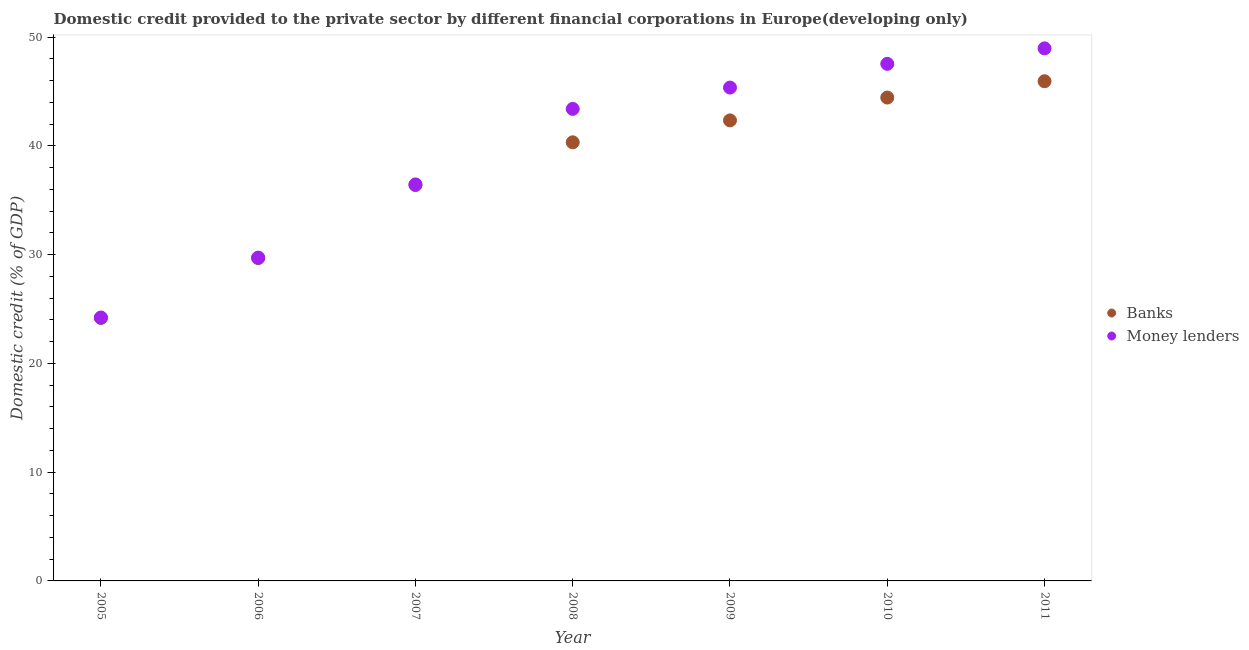Is the number of dotlines equal to the number of legend labels?
Give a very brief answer. Yes. What is the domestic credit provided by money lenders in 2010?
Your answer should be very brief. 47.54. Across all years, what is the maximum domestic credit provided by banks?
Offer a very short reply. 45.94. Across all years, what is the minimum domestic credit provided by money lenders?
Offer a terse response. 24.22. What is the total domestic credit provided by money lenders in the graph?
Offer a very short reply. 275.65. What is the difference between the domestic credit provided by banks in 2009 and that in 2011?
Your response must be concise. -3.6. What is the difference between the domestic credit provided by money lenders in 2007 and the domestic credit provided by banks in 2008?
Ensure brevity in your answer.  -3.87. What is the average domestic credit provided by money lenders per year?
Offer a very short reply. 39.38. In the year 2008, what is the difference between the domestic credit provided by banks and domestic credit provided by money lenders?
Provide a short and direct response. -3.07. In how many years, is the domestic credit provided by banks greater than 6 %?
Keep it short and to the point. 7. What is the ratio of the domestic credit provided by money lenders in 2005 to that in 2010?
Keep it short and to the point. 0.51. What is the difference between the highest and the second highest domestic credit provided by money lenders?
Give a very brief answer. 1.42. What is the difference between the highest and the lowest domestic credit provided by banks?
Make the answer very short. 21.76. In how many years, is the domestic credit provided by money lenders greater than the average domestic credit provided by money lenders taken over all years?
Provide a succinct answer. 4. Does the domestic credit provided by money lenders monotonically increase over the years?
Your response must be concise. Yes. Is the domestic credit provided by banks strictly greater than the domestic credit provided by money lenders over the years?
Provide a succinct answer. No. What is the difference between two consecutive major ticks on the Y-axis?
Your response must be concise. 10. Does the graph contain any zero values?
Provide a short and direct response. No. How many legend labels are there?
Provide a short and direct response. 2. What is the title of the graph?
Keep it short and to the point. Domestic credit provided to the private sector by different financial corporations in Europe(developing only). Does "Measles" appear as one of the legend labels in the graph?
Give a very brief answer. No. What is the label or title of the Y-axis?
Offer a very short reply. Domestic credit (% of GDP). What is the Domestic credit (% of GDP) of Banks in 2005?
Offer a terse response. 24.18. What is the Domestic credit (% of GDP) of Money lenders in 2005?
Offer a very short reply. 24.22. What is the Domestic credit (% of GDP) of Banks in 2006?
Ensure brevity in your answer.  29.68. What is the Domestic credit (% of GDP) of Money lenders in 2006?
Give a very brief answer. 29.73. What is the Domestic credit (% of GDP) of Banks in 2007?
Your answer should be compact. 36.39. What is the Domestic credit (% of GDP) of Money lenders in 2007?
Provide a short and direct response. 36.45. What is the Domestic credit (% of GDP) of Banks in 2008?
Provide a succinct answer. 40.32. What is the Domestic credit (% of GDP) of Money lenders in 2008?
Your answer should be very brief. 43.4. What is the Domestic credit (% of GDP) in Banks in 2009?
Your response must be concise. 42.34. What is the Domestic credit (% of GDP) of Money lenders in 2009?
Your response must be concise. 45.36. What is the Domestic credit (% of GDP) in Banks in 2010?
Give a very brief answer. 44.44. What is the Domestic credit (% of GDP) of Money lenders in 2010?
Keep it short and to the point. 47.54. What is the Domestic credit (% of GDP) in Banks in 2011?
Your answer should be compact. 45.94. What is the Domestic credit (% of GDP) in Money lenders in 2011?
Provide a succinct answer. 48.96. Across all years, what is the maximum Domestic credit (% of GDP) of Banks?
Offer a very short reply. 45.94. Across all years, what is the maximum Domestic credit (% of GDP) in Money lenders?
Give a very brief answer. 48.96. Across all years, what is the minimum Domestic credit (% of GDP) in Banks?
Provide a succinct answer. 24.18. Across all years, what is the minimum Domestic credit (% of GDP) in Money lenders?
Your response must be concise. 24.22. What is the total Domestic credit (% of GDP) of Banks in the graph?
Offer a terse response. 263.29. What is the total Domestic credit (% of GDP) in Money lenders in the graph?
Offer a terse response. 275.65. What is the difference between the Domestic credit (% of GDP) of Banks in 2005 and that in 2006?
Give a very brief answer. -5.5. What is the difference between the Domestic credit (% of GDP) of Money lenders in 2005 and that in 2006?
Make the answer very short. -5.51. What is the difference between the Domestic credit (% of GDP) in Banks in 2005 and that in 2007?
Your answer should be compact. -12.21. What is the difference between the Domestic credit (% of GDP) of Money lenders in 2005 and that in 2007?
Make the answer very short. -12.24. What is the difference between the Domestic credit (% of GDP) of Banks in 2005 and that in 2008?
Make the answer very short. -16.15. What is the difference between the Domestic credit (% of GDP) in Money lenders in 2005 and that in 2008?
Keep it short and to the point. -19.18. What is the difference between the Domestic credit (% of GDP) of Banks in 2005 and that in 2009?
Offer a very short reply. -18.16. What is the difference between the Domestic credit (% of GDP) of Money lenders in 2005 and that in 2009?
Make the answer very short. -21.14. What is the difference between the Domestic credit (% of GDP) in Banks in 2005 and that in 2010?
Ensure brevity in your answer.  -20.26. What is the difference between the Domestic credit (% of GDP) in Money lenders in 2005 and that in 2010?
Your answer should be compact. -23.32. What is the difference between the Domestic credit (% of GDP) in Banks in 2005 and that in 2011?
Give a very brief answer. -21.76. What is the difference between the Domestic credit (% of GDP) of Money lenders in 2005 and that in 2011?
Offer a very short reply. -24.75. What is the difference between the Domestic credit (% of GDP) of Banks in 2006 and that in 2007?
Offer a very short reply. -6.72. What is the difference between the Domestic credit (% of GDP) in Money lenders in 2006 and that in 2007?
Provide a short and direct response. -6.73. What is the difference between the Domestic credit (% of GDP) of Banks in 2006 and that in 2008?
Ensure brevity in your answer.  -10.65. What is the difference between the Domestic credit (% of GDP) in Money lenders in 2006 and that in 2008?
Offer a very short reply. -13.67. What is the difference between the Domestic credit (% of GDP) in Banks in 2006 and that in 2009?
Make the answer very short. -12.66. What is the difference between the Domestic credit (% of GDP) in Money lenders in 2006 and that in 2009?
Your answer should be very brief. -15.63. What is the difference between the Domestic credit (% of GDP) of Banks in 2006 and that in 2010?
Keep it short and to the point. -14.76. What is the difference between the Domestic credit (% of GDP) of Money lenders in 2006 and that in 2010?
Your answer should be compact. -17.81. What is the difference between the Domestic credit (% of GDP) of Banks in 2006 and that in 2011?
Your answer should be compact. -16.26. What is the difference between the Domestic credit (% of GDP) in Money lenders in 2006 and that in 2011?
Your answer should be compact. -19.24. What is the difference between the Domestic credit (% of GDP) of Banks in 2007 and that in 2008?
Your answer should be very brief. -3.93. What is the difference between the Domestic credit (% of GDP) in Money lenders in 2007 and that in 2008?
Offer a very short reply. -6.94. What is the difference between the Domestic credit (% of GDP) in Banks in 2007 and that in 2009?
Offer a terse response. -5.95. What is the difference between the Domestic credit (% of GDP) of Money lenders in 2007 and that in 2009?
Your answer should be compact. -8.9. What is the difference between the Domestic credit (% of GDP) in Banks in 2007 and that in 2010?
Your answer should be compact. -8.04. What is the difference between the Domestic credit (% of GDP) in Money lenders in 2007 and that in 2010?
Keep it short and to the point. -11.08. What is the difference between the Domestic credit (% of GDP) in Banks in 2007 and that in 2011?
Your answer should be compact. -9.55. What is the difference between the Domestic credit (% of GDP) of Money lenders in 2007 and that in 2011?
Ensure brevity in your answer.  -12.51. What is the difference between the Domestic credit (% of GDP) of Banks in 2008 and that in 2009?
Your answer should be compact. -2.01. What is the difference between the Domestic credit (% of GDP) in Money lenders in 2008 and that in 2009?
Give a very brief answer. -1.96. What is the difference between the Domestic credit (% of GDP) of Banks in 2008 and that in 2010?
Ensure brevity in your answer.  -4.11. What is the difference between the Domestic credit (% of GDP) of Money lenders in 2008 and that in 2010?
Provide a succinct answer. -4.14. What is the difference between the Domestic credit (% of GDP) of Banks in 2008 and that in 2011?
Your answer should be very brief. -5.62. What is the difference between the Domestic credit (% of GDP) in Money lenders in 2008 and that in 2011?
Provide a short and direct response. -5.57. What is the difference between the Domestic credit (% of GDP) in Banks in 2009 and that in 2010?
Your answer should be compact. -2.1. What is the difference between the Domestic credit (% of GDP) in Money lenders in 2009 and that in 2010?
Keep it short and to the point. -2.18. What is the difference between the Domestic credit (% of GDP) in Banks in 2009 and that in 2011?
Make the answer very short. -3.6. What is the difference between the Domestic credit (% of GDP) in Money lenders in 2009 and that in 2011?
Provide a short and direct response. -3.6. What is the difference between the Domestic credit (% of GDP) of Banks in 2010 and that in 2011?
Provide a short and direct response. -1.5. What is the difference between the Domestic credit (% of GDP) of Money lenders in 2010 and that in 2011?
Your response must be concise. -1.42. What is the difference between the Domestic credit (% of GDP) in Banks in 2005 and the Domestic credit (% of GDP) in Money lenders in 2006?
Make the answer very short. -5.55. What is the difference between the Domestic credit (% of GDP) in Banks in 2005 and the Domestic credit (% of GDP) in Money lenders in 2007?
Provide a succinct answer. -12.28. What is the difference between the Domestic credit (% of GDP) in Banks in 2005 and the Domestic credit (% of GDP) in Money lenders in 2008?
Your answer should be very brief. -19.22. What is the difference between the Domestic credit (% of GDP) of Banks in 2005 and the Domestic credit (% of GDP) of Money lenders in 2009?
Ensure brevity in your answer.  -21.18. What is the difference between the Domestic credit (% of GDP) of Banks in 2005 and the Domestic credit (% of GDP) of Money lenders in 2010?
Ensure brevity in your answer.  -23.36. What is the difference between the Domestic credit (% of GDP) of Banks in 2005 and the Domestic credit (% of GDP) of Money lenders in 2011?
Make the answer very short. -24.78. What is the difference between the Domestic credit (% of GDP) in Banks in 2006 and the Domestic credit (% of GDP) in Money lenders in 2007?
Your answer should be compact. -6.78. What is the difference between the Domestic credit (% of GDP) of Banks in 2006 and the Domestic credit (% of GDP) of Money lenders in 2008?
Your answer should be compact. -13.72. What is the difference between the Domestic credit (% of GDP) of Banks in 2006 and the Domestic credit (% of GDP) of Money lenders in 2009?
Your response must be concise. -15.68. What is the difference between the Domestic credit (% of GDP) of Banks in 2006 and the Domestic credit (% of GDP) of Money lenders in 2010?
Keep it short and to the point. -17.86. What is the difference between the Domestic credit (% of GDP) of Banks in 2006 and the Domestic credit (% of GDP) of Money lenders in 2011?
Ensure brevity in your answer.  -19.28. What is the difference between the Domestic credit (% of GDP) of Banks in 2007 and the Domestic credit (% of GDP) of Money lenders in 2008?
Offer a very short reply. -7. What is the difference between the Domestic credit (% of GDP) in Banks in 2007 and the Domestic credit (% of GDP) in Money lenders in 2009?
Your response must be concise. -8.96. What is the difference between the Domestic credit (% of GDP) of Banks in 2007 and the Domestic credit (% of GDP) of Money lenders in 2010?
Ensure brevity in your answer.  -11.14. What is the difference between the Domestic credit (% of GDP) of Banks in 2007 and the Domestic credit (% of GDP) of Money lenders in 2011?
Your response must be concise. -12.57. What is the difference between the Domestic credit (% of GDP) in Banks in 2008 and the Domestic credit (% of GDP) in Money lenders in 2009?
Your answer should be very brief. -5.03. What is the difference between the Domestic credit (% of GDP) of Banks in 2008 and the Domestic credit (% of GDP) of Money lenders in 2010?
Ensure brevity in your answer.  -7.21. What is the difference between the Domestic credit (% of GDP) in Banks in 2008 and the Domestic credit (% of GDP) in Money lenders in 2011?
Your response must be concise. -8.64. What is the difference between the Domestic credit (% of GDP) of Banks in 2009 and the Domestic credit (% of GDP) of Money lenders in 2010?
Provide a succinct answer. -5.2. What is the difference between the Domestic credit (% of GDP) of Banks in 2009 and the Domestic credit (% of GDP) of Money lenders in 2011?
Ensure brevity in your answer.  -6.62. What is the difference between the Domestic credit (% of GDP) in Banks in 2010 and the Domestic credit (% of GDP) in Money lenders in 2011?
Keep it short and to the point. -4.52. What is the average Domestic credit (% of GDP) in Banks per year?
Offer a terse response. 37.61. What is the average Domestic credit (% of GDP) in Money lenders per year?
Your answer should be very brief. 39.38. In the year 2005, what is the difference between the Domestic credit (% of GDP) in Banks and Domestic credit (% of GDP) in Money lenders?
Give a very brief answer. -0.04. In the year 2006, what is the difference between the Domestic credit (% of GDP) of Banks and Domestic credit (% of GDP) of Money lenders?
Your answer should be very brief. -0.05. In the year 2007, what is the difference between the Domestic credit (% of GDP) of Banks and Domestic credit (% of GDP) of Money lenders?
Keep it short and to the point. -0.06. In the year 2008, what is the difference between the Domestic credit (% of GDP) of Banks and Domestic credit (% of GDP) of Money lenders?
Ensure brevity in your answer.  -3.07. In the year 2009, what is the difference between the Domestic credit (% of GDP) of Banks and Domestic credit (% of GDP) of Money lenders?
Your response must be concise. -3.02. In the year 2010, what is the difference between the Domestic credit (% of GDP) in Banks and Domestic credit (% of GDP) in Money lenders?
Your answer should be compact. -3.1. In the year 2011, what is the difference between the Domestic credit (% of GDP) in Banks and Domestic credit (% of GDP) in Money lenders?
Keep it short and to the point. -3.02. What is the ratio of the Domestic credit (% of GDP) of Banks in 2005 to that in 2006?
Your response must be concise. 0.81. What is the ratio of the Domestic credit (% of GDP) of Money lenders in 2005 to that in 2006?
Your response must be concise. 0.81. What is the ratio of the Domestic credit (% of GDP) in Banks in 2005 to that in 2007?
Your answer should be compact. 0.66. What is the ratio of the Domestic credit (% of GDP) in Money lenders in 2005 to that in 2007?
Keep it short and to the point. 0.66. What is the ratio of the Domestic credit (% of GDP) in Banks in 2005 to that in 2008?
Provide a succinct answer. 0.6. What is the ratio of the Domestic credit (% of GDP) of Money lenders in 2005 to that in 2008?
Provide a succinct answer. 0.56. What is the ratio of the Domestic credit (% of GDP) in Banks in 2005 to that in 2009?
Your response must be concise. 0.57. What is the ratio of the Domestic credit (% of GDP) in Money lenders in 2005 to that in 2009?
Make the answer very short. 0.53. What is the ratio of the Domestic credit (% of GDP) of Banks in 2005 to that in 2010?
Your answer should be very brief. 0.54. What is the ratio of the Domestic credit (% of GDP) of Money lenders in 2005 to that in 2010?
Offer a terse response. 0.51. What is the ratio of the Domestic credit (% of GDP) of Banks in 2005 to that in 2011?
Provide a succinct answer. 0.53. What is the ratio of the Domestic credit (% of GDP) of Money lenders in 2005 to that in 2011?
Offer a very short reply. 0.49. What is the ratio of the Domestic credit (% of GDP) of Banks in 2006 to that in 2007?
Give a very brief answer. 0.82. What is the ratio of the Domestic credit (% of GDP) in Money lenders in 2006 to that in 2007?
Your response must be concise. 0.82. What is the ratio of the Domestic credit (% of GDP) in Banks in 2006 to that in 2008?
Offer a very short reply. 0.74. What is the ratio of the Domestic credit (% of GDP) in Money lenders in 2006 to that in 2008?
Provide a succinct answer. 0.69. What is the ratio of the Domestic credit (% of GDP) of Banks in 2006 to that in 2009?
Your answer should be very brief. 0.7. What is the ratio of the Domestic credit (% of GDP) in Money lenders in 2006 to that in 2009?
Give a very brief answer. 0.66. What is the ratio of the Domestic credit (% of GDP) in Banks in 2006 to that in 2010?
Your answer should be compact. 0.67. What is the ratio of the Domestic credit (% of GDP) in Money lenders in 2006 to that in 2010?
Offer a very short reply. 0.63. What is the ratio of the Domestic credit (% of GDP) in Banks in 2006 to that in 2011?
Your response must be concise. 0.65. What is the ratio of the Domestic credit (% of GDP) of Money lenders in 2006 to that in 2011?
Ensure brevity in your answer.  0.61. What is the ratio of the Domestic credit (% of GDP) of Banks in 2007 to that in 2008?
Your answer should be compact. 0.9. What is the ratio of the Domestic credit (% of GDP) of Money lenders in 2007 to that in 2008?
Offer a very short reply. 0.84. What is the ratio of the Domestic credit (% of GDP) in Banks in 2007 to that in 2009?
Ensure brevity in your answer.  0.86. What is the ratio of the Domestic credit (% of GDP) of Money lenders in 2007 to that in 2009?
Give a very brief answer. 0.8. What is the ratio of the Domestic credit (% of GDP) of Banks in 2007 to that in 2010?
Offer a terse response. 0.82. What is the ratio of the Domestic credit (% of GDP) of Money lenders in 2007 to that in 2010?
Ensure brevity in your answer.  0.77. What is the ratio of the Domestic credit (% of GDP) in Banks in 2007 to that in 2011?
Provide a succinct answer. 0.79. What is the ratio of the Domestic credit (% of GDP) in Money lenders in 2007 to that in 2011?
Provide a short and direct response. 0.74. What is the ratio of the Domestic credit (% of GDP) of Banks in 2008 to that in 2009?
Ensure brevity in your answer.  0.95. What is the ratio of the Domestic credit (% of GDP) in Money lenders in 2008 to that in 2009?
Your response must be concise. 0.96. What is the ratio of the Domestic credit (% of GDP) of Banks in 2008 to that in 2010?
Your answer should be compact. 0.91. What is the ratio of the Domestic credit (% of GDP) of Money lenders in 2008 to that in 2010?
Your response must be concise. 0.91. What is the ratio of the Domestic credit (% of GDP) of Banks in 2008 to that in 2011?
Your answer should be compact. 0.88. What is the ratio of the Domestic credit (% of GDP) in Money lenders in 2008 to that in 2011?
Your answer should be compact. 0.89. What is the ratio of the Domestic credit (% of GDP) of Banks in 2009 to that in 2010?
Offer a very short reply. 0.95. What is the ratio of the Domestic credit (% of GDP) of Money lenders in 2009 to that in 2010?
Your response must be concise. 0.95. What is the ratio of the Domestic credit (% of GDP) in Banks in 2009 to that in 2011?
Give a very brief answer. 0.92. What is the ratio of the Domestic credit (% of GDP) of Money lenders in 2009 to that in 2011?
Your answer should be compact. 0.93. What is the ratio of the Domestic credit (% of GDP) of Banks in 2010 to that in 2011?
Give a very brief answer. 0.97. What is the ratio of the Domestic credit (% of GDP) of Money lenders in 2010 to that in 2011?
Your answer should be compact. 0.97. What is the difference between the highest and the second highest Domestic credit (% of GDP) of Banks?
Make the answer very short. 1.5. What is the difference between the highest and the second highest Domestic credit (% of GDP) of Money lenders?
Offer a very short reply. 1.42. What is the difference between the highest and the lowest Domestic credit (% of GDP) of Banks?
Make the answer very short. 21.76. What is the difference between the highest and the lowest Domestic credit (% of GDP) of Money lenders?
Your answer should be compact. 24.75. 